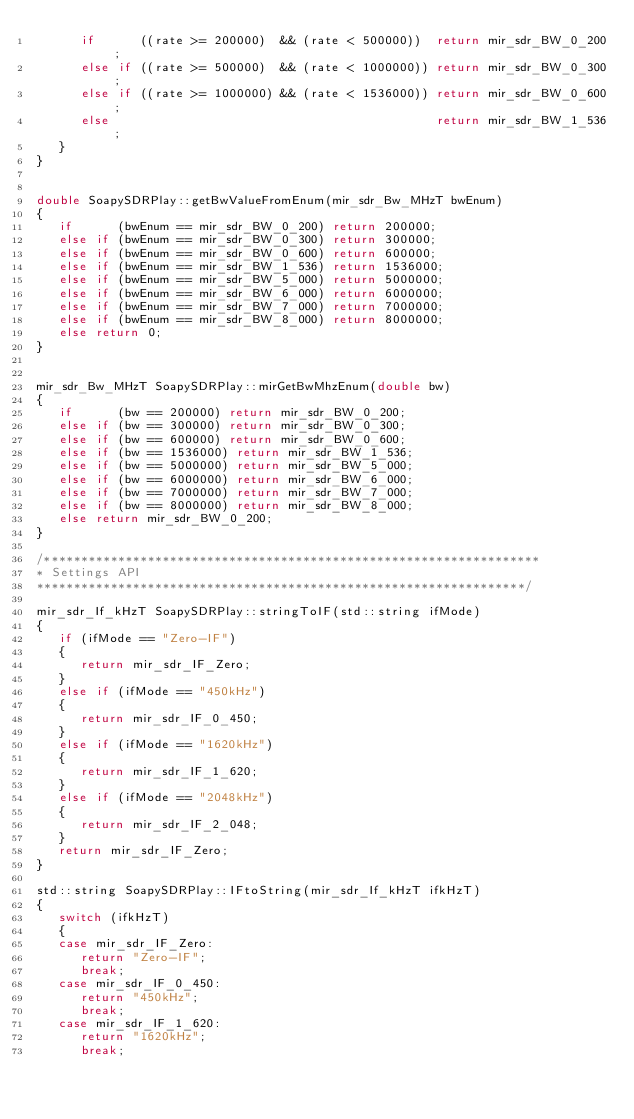<code> <loc_0><loc_0><loc_500><loc_500><_C++_>      if      ((rate >= 200000)  && (rate < 500000))  return mir_sdr_BW_0_200;
      else if ((rate >= 500000)  && (rate < 1000000)) return mir_sdr_BW_0_300;
      else if ((rate >= 1000000) && (rate < 1536000)) return mir_sdr_BW_0_600;
      else                                            return mir_sdr_BW_1_536;
   }
}


double SoapySDRPlay::getBwValueFromEnum(mir_sdr_Bw_MHzT bwEnum)
{
   if      (bwEnum == mir_sdr_BW_0_200) return 200000;
   else if (bwEnum == mir_sdr_BW_0_300) return 300000;
   else if (bwEnum == mir_sdr_BW_0_600) return 600000;
   else if (bwEnum == mir_sdr_BW_1_536) return 1536000;
   else if (bwEnum == mir_sdr_BW_5_000) return 5000000;
   else if (bwEnum == mir_sdr_BW_6_000) return 6000000;
   else if (bwEnum == mir_sdr_BW_7_000) return 7000000;
   else if (bwEnum == mir_sdr_BW_8_000) return 8000000;
   else return 0;
}


mir_sdr_Bw_MHzT SoapySDRPlay::mirGetBwMhzEnum(double bw)
{
   if      (bw == 200000) return mir_sdr_BW_0_200;
   else if (bw == 300000) return mir_sdr_BW_0_300;
   else if (bw == 600000) return mir_sdr_BW_0_600;
   else if (bw == 1536000) return mir_sdr_BW_1_536;
   else if (bw == 5000000) return mir_sdr_BW_5_000;
   else if (bw == 6000000) return mir_sdr_BW_6_000;
   else if (bw == 7000000) return mir_sdr_BW_7_000;
   else if (bw == 8000000) return mir_sdr_BW_8_000;
   else return mir_sdr_BW_0_200;
}

/*******************************************************************
* Settings API
******************************************************************/

mir_sdr_If_kHzT SoapySDRPlay::stringToIF(std::string ifMode)
{
   if (ifMode == "Zero-IF")
   {
      return mir_sdr_IF_Zero;
   }
   else if (ifMode == "450kHz")
   {
      return mir_sdr_IF_0_450;
   }
   else if (ifMode == "1620kHz")
   {
      return mir_sdr_IF_1_620;
   }
   else if (ifMode == "2048kHz")
   {
      return mir_sdr_IF_2_048;
   }
   return mir_sdr_IF_Zero;
}

std::string SoapySDRPlay::IFtoString(mir_sdr_If_kHzT ifkHzT)
{
   switch (ifkHzT)
   {
   case mir_sdr_IF_Zero:
      return "Zero-IF";
      break;
   case mir_sdr_IF_0_450:
      return "450kHz";
      break;
   case mir_sdr_IF_1_620:
      return "1620kHz";
      break;</code> 